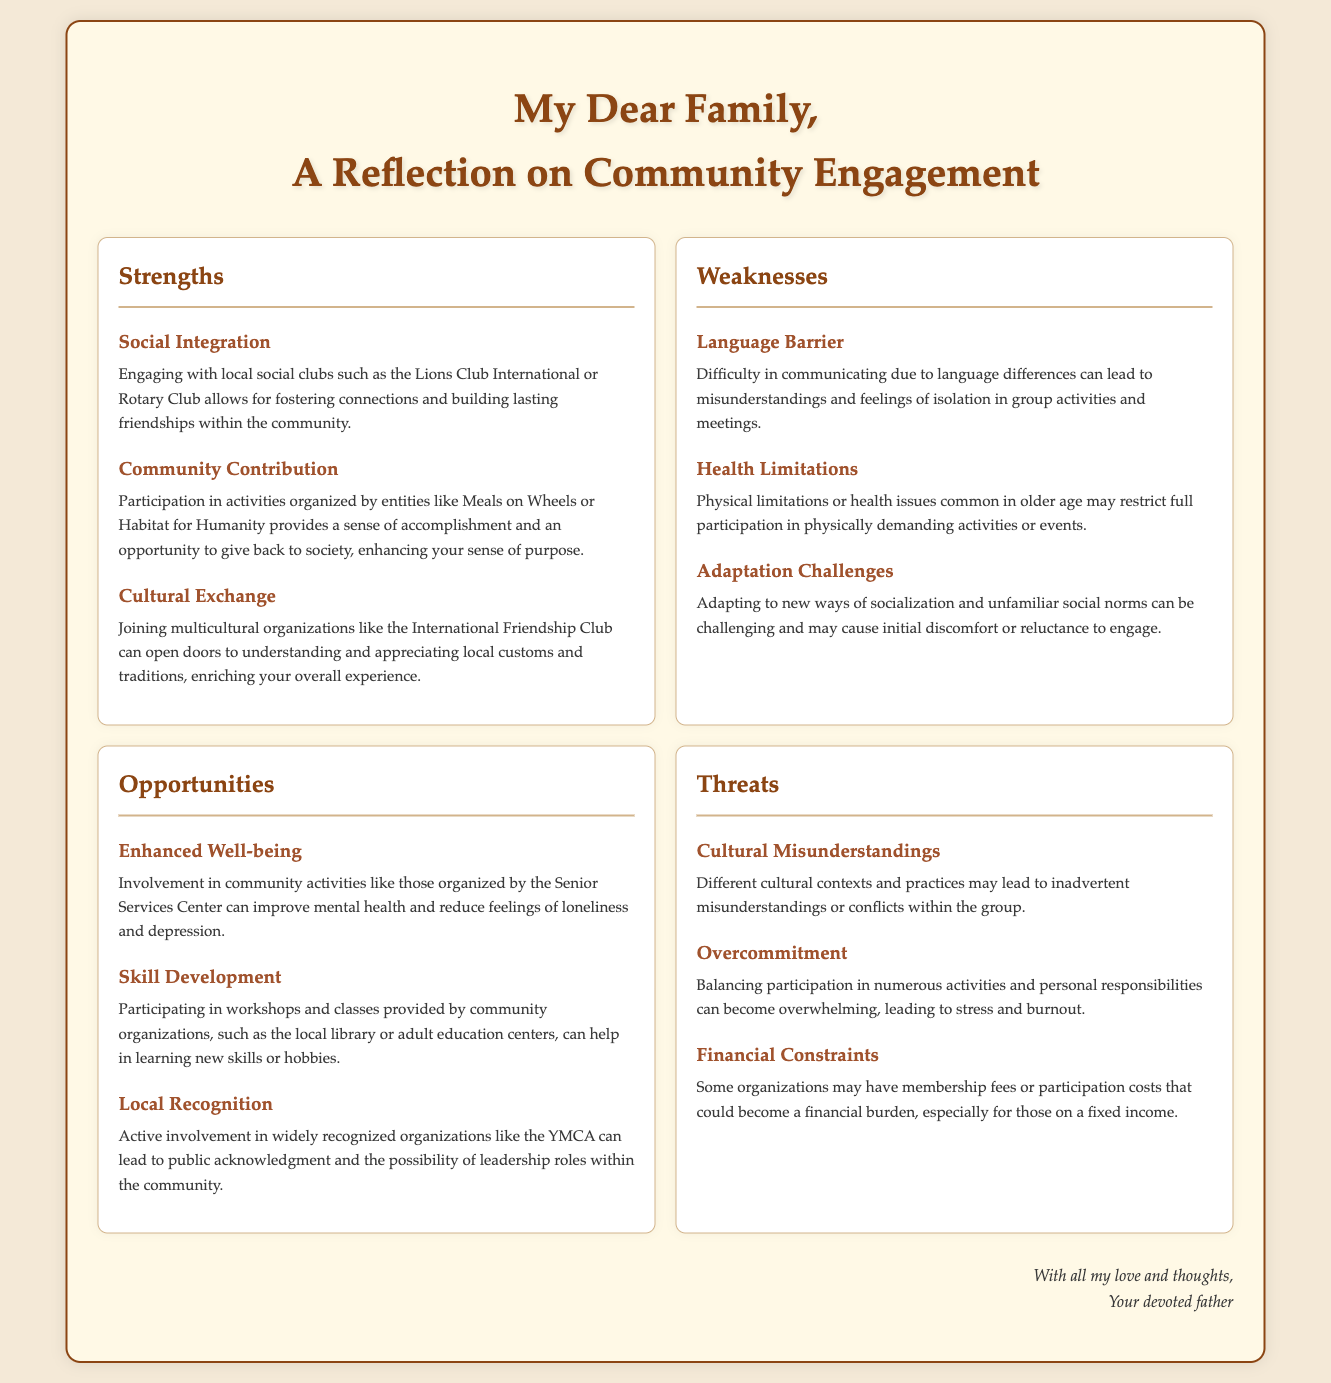what is the title of the document? The title is presented at the top of the document, stating the purpose of the analysis.
Answer: Community Participation: A SWOT Analysis how many strengths are listed? The document outlines three strengths associated with community participation.
Answer: 3 name one social club mentioned in the strengths section. The strengths section highlights specific organizations that individuals can engage with for social integration.
Answer: Lions Club International what is one weakness related to health? The weaknesses section discusses limitations that may affect participation, specifically regarding health.
Answer: Health Limitations which opportunity is associated with improved mental health? The document specifies activities that can enhance well-being for participants.
Answer: Enhanced Well-being what is a threat related to financial constraints? The threats section details potential issues that may arise from financial responsibilities related to community engagement.
Answer: Financial Constraints how many opportunities are outlined in the document? The opportunities section contains details on the benefits of community involvement.
Answer: 3 what does the reasoning section suggest about cultural misunderstandings? The threats section highlights the potential challenges that may arise from differing cultural contexts in community activities.
Answer: Cultural Misunderstandings 